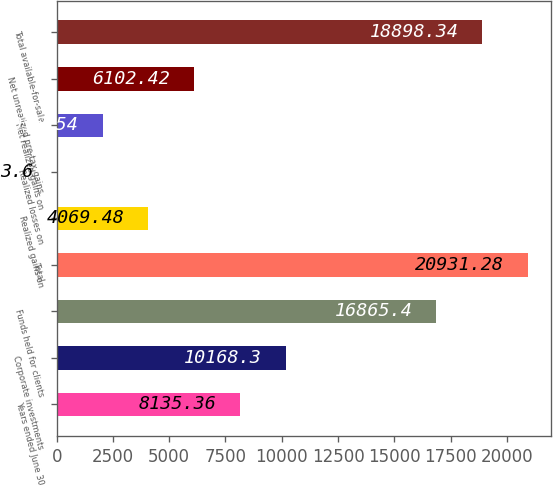<chart> <loc_0><loc_0><loc_500><loc_500><bar_chart><fcel>Years ended June 30<fcel>Corporate investments<fcel>Funds held for clients<fcel>Total<fcel>Realized gains on<fcel>Realized losses on<fcel>Net realized gains on<fcel>Net unrealized pre-tax gains<fcel>Total available-for-sale<nl><fcel>8135.36<fcel>10168.3<fcel>16865.4<fcel>20931.3<fcel>4069.48<fcel>3.6<fcel>2036.54<fcel>6102.42<fcel>18898.3<nl></chart> 